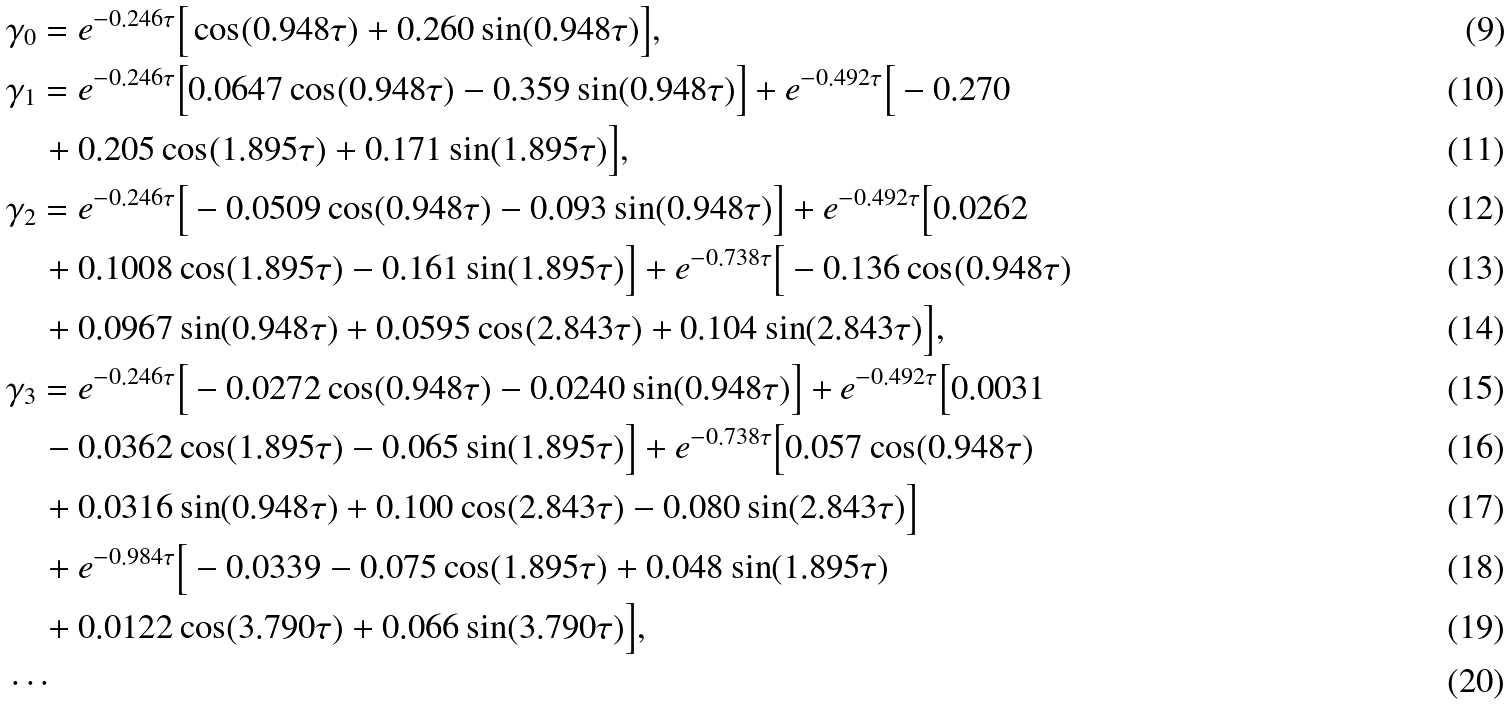Convert formula to latex. <formula><loc_0><loc_0><loc_500><loc_500>& \gamma _ { 0 } = e ^ { - 0 . 2 4 6 \tau } \Big { [ } \cos ( 0 . 9 4 8 \tau ) + 0 . 2 6 0 \sin ( 0 . 9 4 8 \tau ) \Big { ] } , \\ & \gamma _ { 1 } = e ^ { - 0 . 2 4 6 \tau } \Big { [ } 0 . 0 6 4 7 \cos ( 0 . 9 4 8 \tau ) - 0 . 3 5 9 \sin ( 0 . 9 4 8 \tau ) \Big { ] } + e ^ { - 0 . 4 9 2 \tau } \Big { [ } - 0 . 2 7 0 \\ & \quad + 0 . 2 0 5 \cos ( 1 . 8 9 5 \tau ) + 0 . 1 7 1 \sin ( 1 . 8 9 5 \tau ) \Big { ] } , \\ & \gamma _ { 2 } = e ^ { - 0 . 2 4 6 \tau } \Big { [ } - 0 . 0 5 0 9 \cos ( 0 . 9 4 8 \tau ) - 0 . 0 9 3 \sin ( 0 . 9 4 8 \tau ) \Big { ] } + e ^ { - 0 . 4 9 2 \tau } \Big { [ } 0 . 0 2 6 2 \\ & \quad + 0 . 1 0 0 8 \cos ( 1 . 8 9 5 \tau ) - 0 . 1 6 1 \sin ( 1 . 8 9 5 \tau ) \Big { ] } + e ^ { - 0 . 7 3 8 \tau } \Big { [ } - 0 . 1 3 6 \cos ( 0 . 9 4 8 \tau ) \\ & \quad + 0 . 0 9 6 7 \sin ( 0 . 9 4 8 \tau ) + 0 . 0 5 9 5 \cos ( 2 . 8 4 3 \tau ) + 0 . 1 0 4 \sin ( 2 . 8 4 3 \tau ) \Big { ] } , \\ & \gamma _ { 3 } = e ^ { - 0 . 2 4 6 \tau } \Big { [ } - 0 . 0 2 7 2 \cos ( 0 . 9 4 8 \tau ) - 0 . 0 2 4 0 \sin ( 0 . 9 4 8 \tau ) \Big { ] } + e ^ { - 0 . 4 9 2 \tau } \Big { [ } 0 . 0 0 3 1 \\ & \quad - 0 . 0 3 6 2 \cos ( 1 . 8 9 5 \tau ) - 0 . 0 6 5 \sin ( 1 . 8 9 5 \tau ) \Big { ] } + e ^ { - 0 . 7 3 8 \tau } \Big { [ } 0 . 0 5 7 \cos ( 0 . 9 4 8 \tau ) \\ & \quad + 0 . 0 3 1 6 \sin ( 0 . 9 4 8 \tau ) + 0 . 1 0 0 \cos ( 2 . 8 4 3 \tau ) - 0 . 0 8 0 \sin ( 2 . 8 4 3 \tau ) \Big { ] } \\ & \quad + e ^ { - 0 . 9 8 4 \tau } \Big { [ } - 0 . 0 3 3 9 - 0 . 0 7 5 \cos ( 1 . 8 9 5 \tau ) + 0 . 0 4 8 \sin ( 1 . 8 9 5 \tau ) \\ & \quad + 0 . 0 1 2 2 \cos ( 3 . 7 9 0 \tau ) + 0 . 0 6 6 \sin ( 3 . 7 9 0 \tau ) \Big { ] } , \\ & \cdots</formula> 